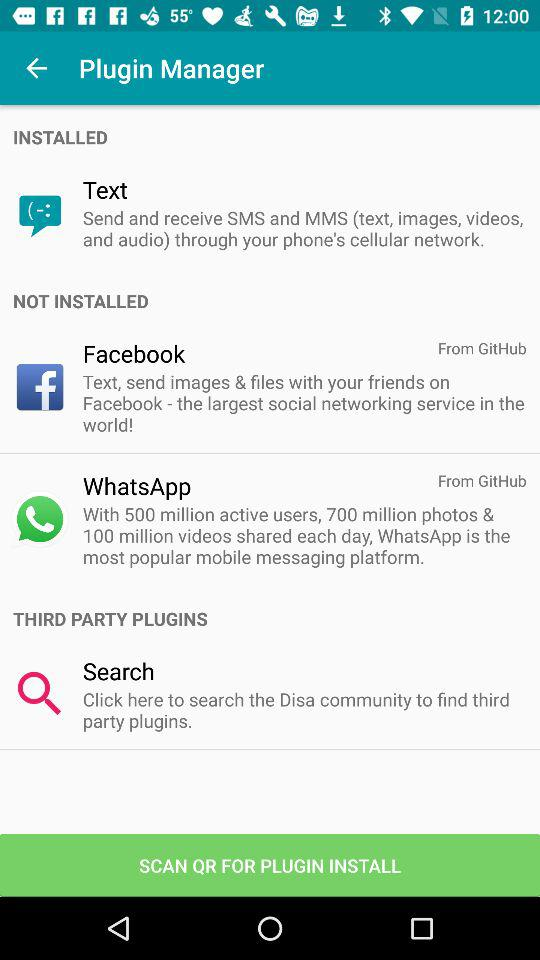What is the third party plugins app name?
When the provided information is insufficient, respond with <no answer>. <no answer> 